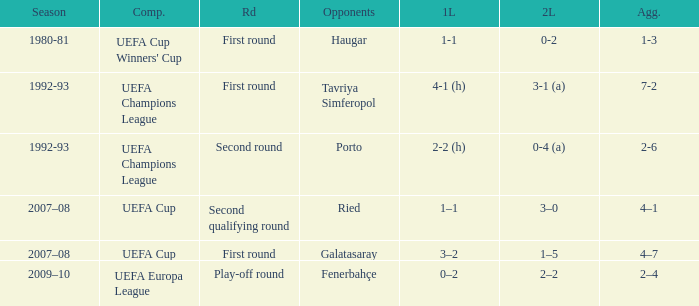 what's the competition where aggregate is 4–7 UEFA Cup. 